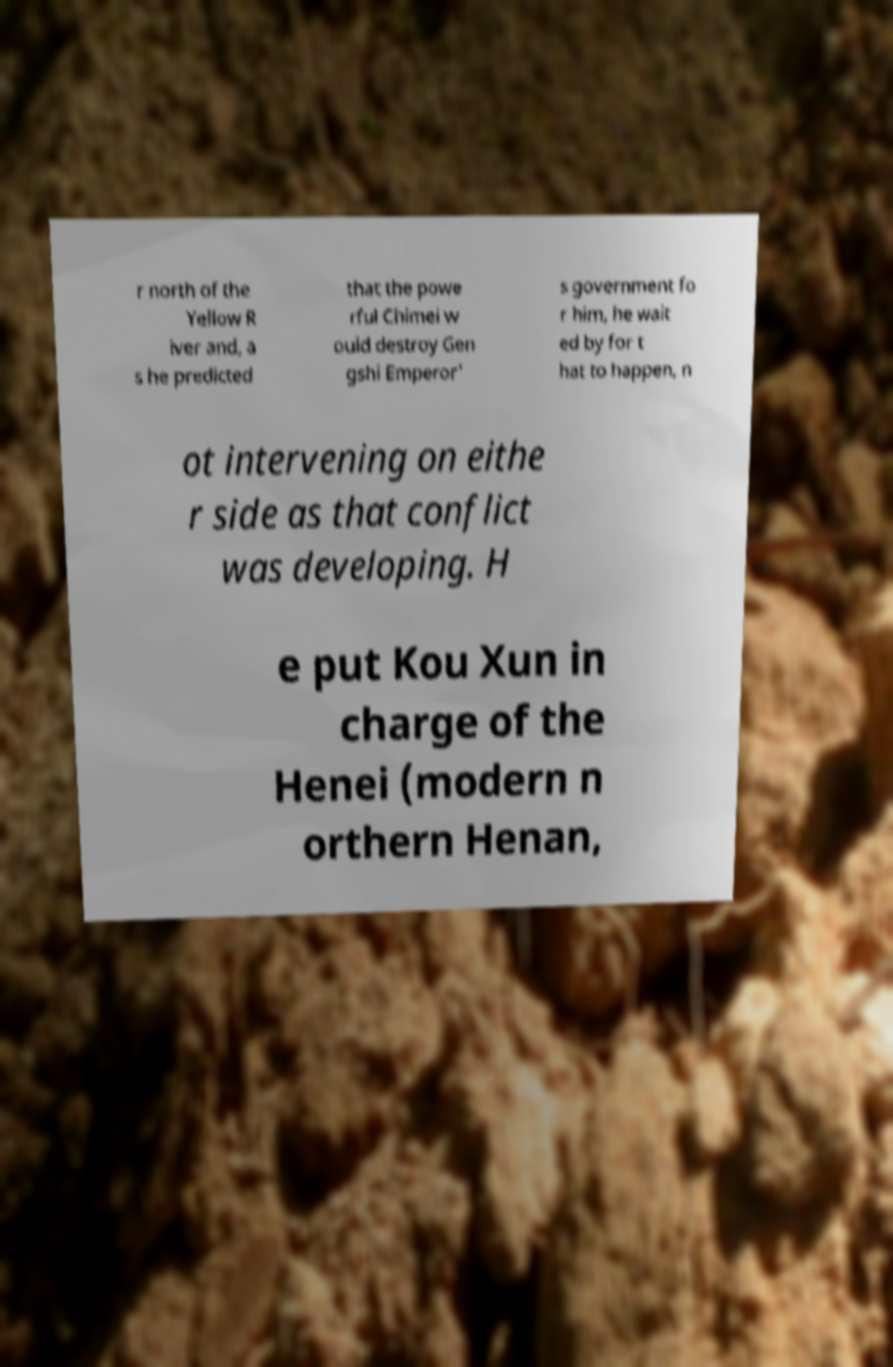What messages or text are displayed in this image? I need them in a readable, typed format. r north of the Yellow R iver and, a s he predicted that the powe rful Chimei w ould destroy Gen gshi Emperor' s government fo r him, he wait ed by for t hat to happen, n ot intervening on eithe r side as that conflict was developing. H e put Kou Xun in charge of the Henei (modern n orthern Henan, 